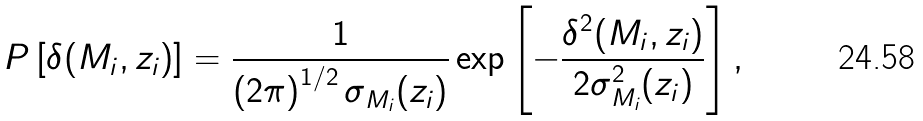Convert formula to latex. <formula><loc_0><loc_0><loc_500><loc_500>P \left [ \delta ( M _ { i } , z _ { i } ) \right ] = \frac { 1 } { \left ( 2 \pi \right ) ^ { 1 / 2 } \sigma _ { M _ { i } } ( z _ { i } ) } \exp \left [ - \frac { \delta ^ { 2 } ( M _ { i } , z _ { i } ) } { 2 \sigma ^ { 2 } _ { M _ { i } } ( z _ { i } ) } \right ] ,</formula> 